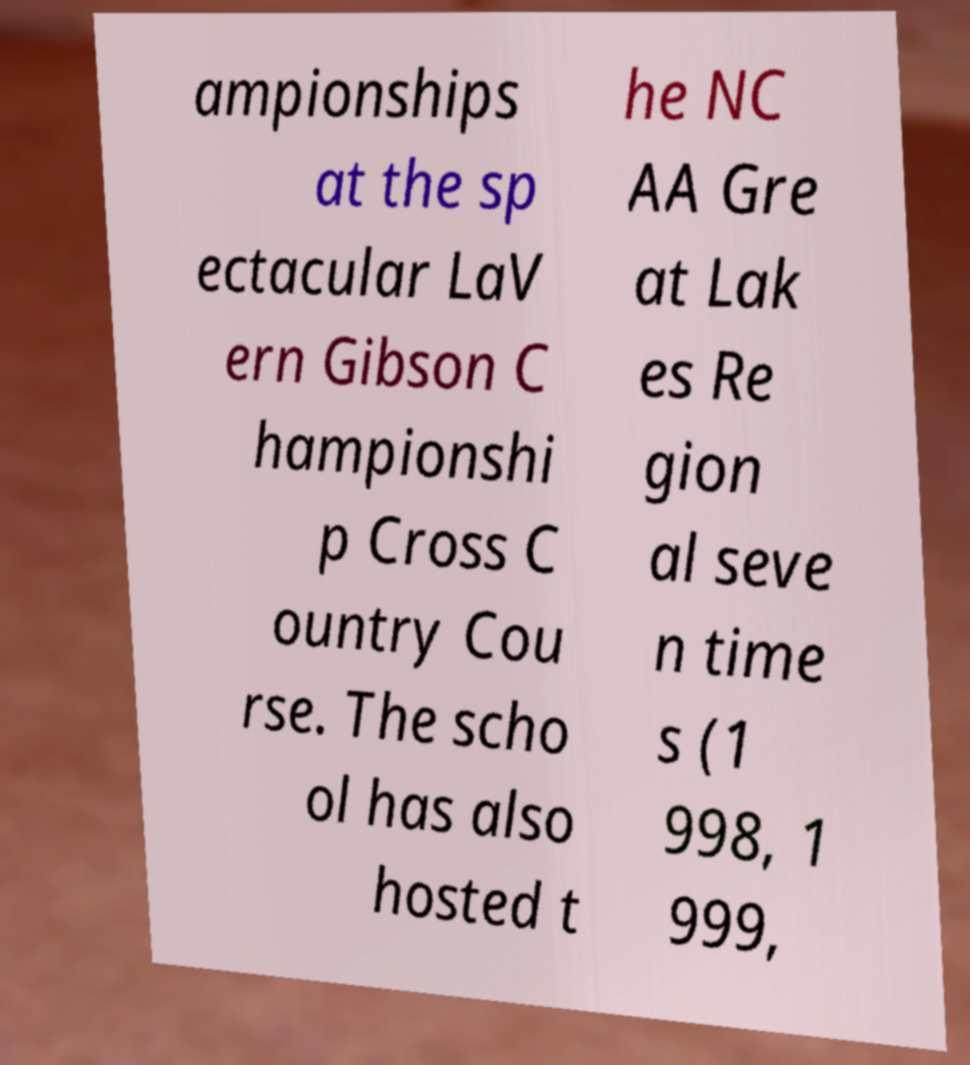What messages or text are displayed in this image? I need them in a readable, typed format. ampionships at the sp ectacular LaV ern Gibson C hampionshi p Cross C ountry Cou rse. The scho ol has also hosted t he NC AA Gre at Lak es Re gion al seve n time s (1 998, 1 999, 